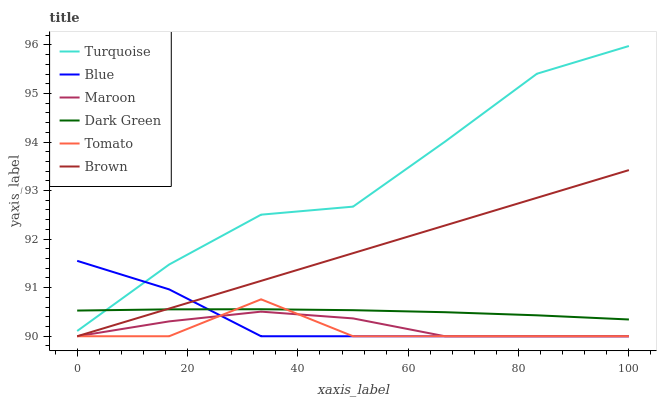Does Tomato have the minimum area under the curve?
Answer yes or no. Yes. Does Turquoise have the maximum area under the curve?
Answer yes or no. Yes. Does Turquoise have the minimum area under the curve?
Answer yes or no. No. Does Tomato have the maximum area under the curve?
Answer yes or no. No. Is Brown the smoothest?
Answer yes or no. Yes. Is Turquoise the roughest?
Answer yes or no. Yes. Is Tomato the smoothest?
Answer yes or no. No. Is Tomato the roughest?
Answer yes or no. No. Does Blue have the lowest value?
Answer yes or no. Yes. Does Turquoise have the lowest value?
Answer yes or no. No. Does Turquoise have the highest value?
Answer yes or no. Yes. Does Tomato have the highest value?
Answer yes or no. No. Is Tomato less than Turquoise?
Answer yes or no. Yes. Is Dark Green greater than Maroon?
Answer yes or no. Yes. Does Brown intersect Tomato?
Answer yes or no. Yes. Is Brown less than Tomato?
Answer yes or no. No. Is Brown greater than Tomato?
Answer yes or no. No. Does Tomato intersect Turquoise?
Answer yes or no. No. 